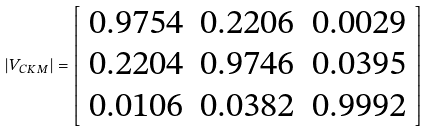<formula> <loc_0><loc_0><loc_500><loc_500>\left | V _ { C K M } \right | = \left [ \begin{array} { l l l } 0 . 9 7 5 4 & 0 . 2 2 0 6 & 0 . 0 0 2 9 \\ 0 . 2 2 0 4 & 0 . 9 7 4 6 & 0 . 0 3 9 5 \\ 0 . 0 1 0 6 & 0 . 0 3 8 2 & 0 . 9 9 9 2 \end{array} \right ]</formula> 